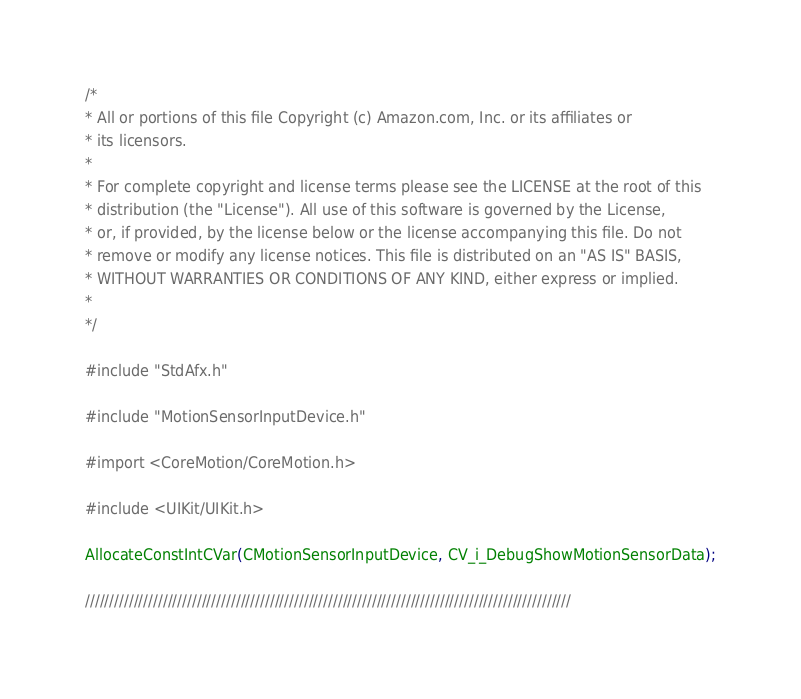Convert code to text. <code><loc_0><loc_0><loc_500><loc_500><_ObjectiveC_>/*
* All or portions of this file Copyright (c) Amazon.com, Inc. or its affiliates or
* its licensors.
*
* For complete copyright and license terms please see the LICENSE at the root of this
* distribution (the "License"). All use of this software is governed by the License,
* or, if provided, by the license below or the license accompanying this file. Do not
* remove or modify any license notices. This file is distributed on an "AS IS" BASIS,
* WITHOUT WARRANTIES OR CONDITIONS OF ANY KIND, either express or implied.
*
*/

#include "StdAfx.h"

#include "MotionSensorInputDevice.h"

#import <CoreMotion/CoreMotion.h>

#include <UIKit/UIKit.h>

AllocateConstIntCVar(CMotionSensorInputDevice, CV_i_DebugShowMotionSensorData);

////////////////////////////////////////////////////////////////////////////////////////////////////</code> 